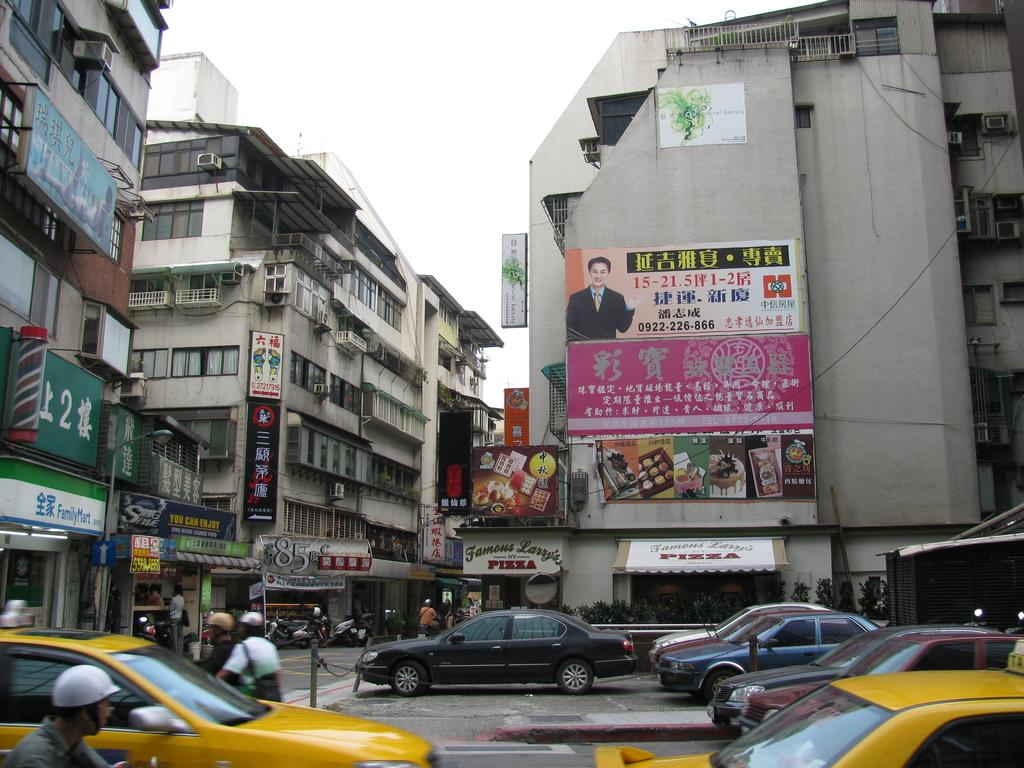<image>
Give a short and clear explanation of the subsequent image. A busy street scene with a pizza shop on the corner. 